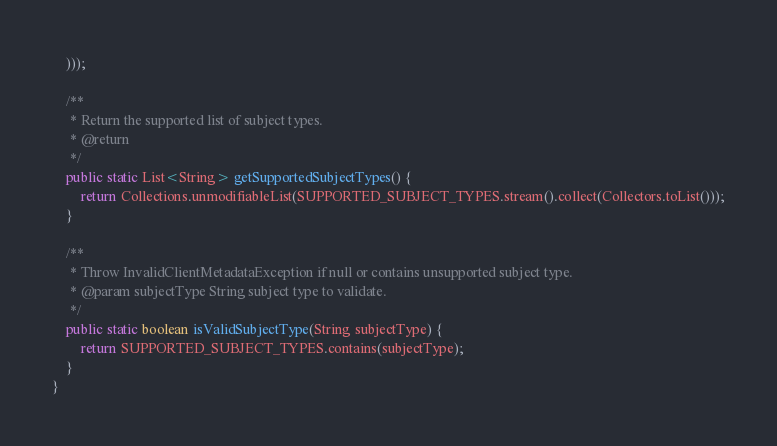<code> <loc_0><loc_0><loc_500><loc_500><_Java_>    )));

    /**
     * Return the supported list of subject types.
     * @return
     */
    public static List<String> getSupportedSubjectTypes() {
        return Collections.unmodifiableList(SUPPORTED_SUBJECT_TYPES.stream().collect(Collectors.toList()));
    }

    /**
     * Throw InvalidClientMetadataException if null or contains unsupported subject type.
     * @param subjectType String subject type to validate.
     */
    public static boolean isValidSubjectType(String subjectType) {
        return SUPPORTED_SUBJECT_TYPES.contains(subjectType);
    }
}
</code> 